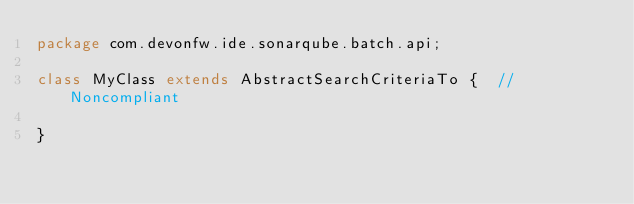Convert code to text. <code><loc_0><loc_0><loc_500><loc_500><_Java_>package com.devonfw.ide.sonarqube.batch.api;

class MyClass extends AbstractSearchCriteriaTo {  // Noncompliant

}</code> 